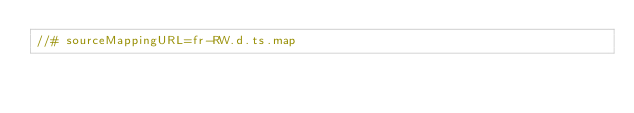<code> <loc_0><loc_0><loc_500><loc_500><_TypeScript_>//# sourceMappingURL=fr-RW.d.ts.map</code> 